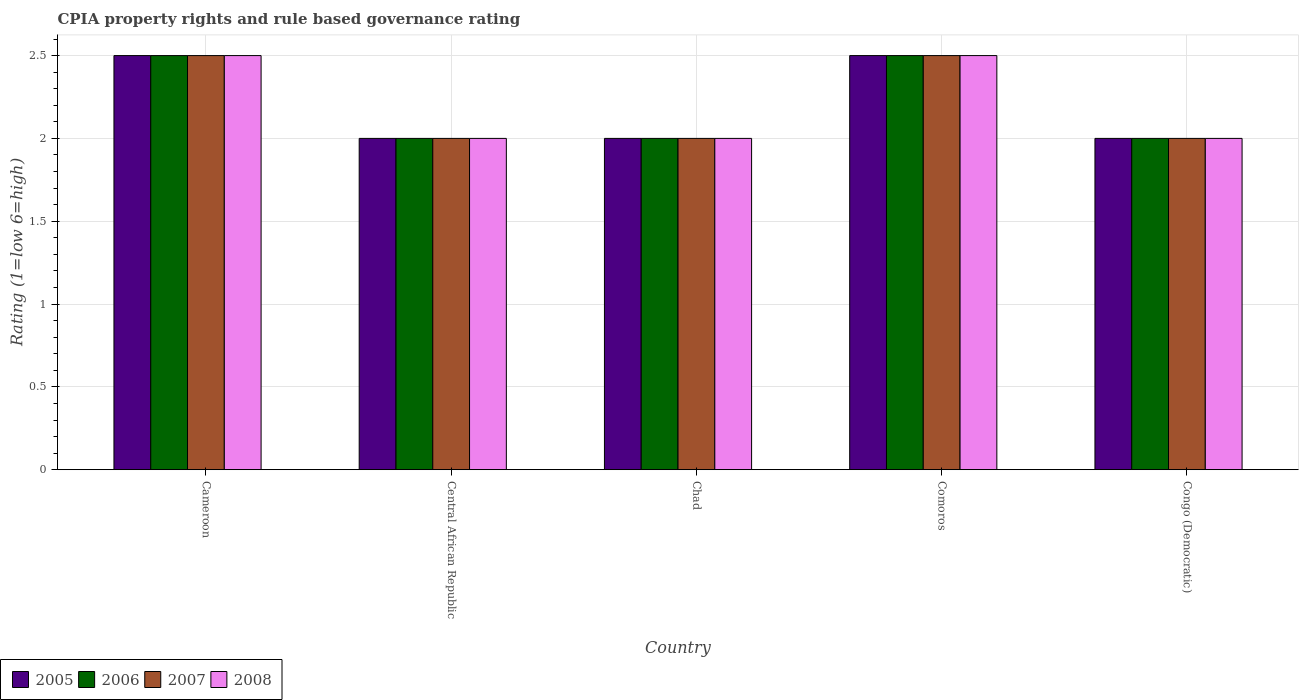How many different coloured bars are there?
Your response must be concise. 4. Are the number of bars on each tick of the X-axis equal?
Give a very brief answer. Yes. How many bars are there on the 4th tick from the right?
Your answer should be compact. 4. What is the label of the 5th group of bars from the left?
Offer a terse response. Congo (Democratic). In how many cases, is the number of bars for a given country not equal to the number of legend labels?
Provide a short and direct response. 0. Across all countries, what is the maximum CPIA rating in 2005?
Provide a succinct answer. 2.5. Across all countries, what is the minimum CPIA rating in 2008?
Offer a terse response. 2. In which country was the CPIA rating in 2008 maximum?
Provide a succinct answer. Cameroon. In which country was the CPIA rating in 2007 minimum?
Provide a short and direct response. Central African Republic. What is the total CPIA rating in 2006 in the graph?
Keep it short and to the point. 11. What is the average CPIA rating in 2005 per country?
Your response must be concise. 2.2. Is the CPIA rating in 2008 in Cameroon less than that in Chad?
Offer a terse response. No. Is the sum of the CPIA rating in 2008 in Cameroon and Comoros greater than the maximum CPIA rating in 2006 across all countries?
Your answer should be compact. Yes. What does the 3rd bar from the left in Comoros represents?
Provide a succinct answer. 2007. How many bars are there?
Offer a terse response. 20. Are all the bars in the graph horizontal?
Provide a short and direct response. No. What is the difference between two consecutive major ticks on the Y-axis?
Make the answer very short. 0.5. Does the graph contain any zero values?
Offer a terse response. No. Where does the legend appear in the graph?
Offer a very short reply. Bottom left. What is the title of the graph?
Offer a very short reply. CPIA property rights and rule based governance rating. What is the label or title of the Y-axis?
Make the answer very short. Rating (1=low 6=high). What is the Rating (1=low 6=high) in 2005 in Cameroon?
Provide a short and direct response. 2.5. What is the Rating (1=low 6=high) in 2007 in Cameroon?
Your answer should be compact. 2.5. What is the Rating (1=low 6=high) of 2008 in Cameroon?
Keep it short and to the point. 2.5. What is the Rating (1=low 6=high) in 2006 in Central African Republic?
Offer a very short reply. 2. What is the Rating (1=low 6=high) in 2005 in Chad?
Your response must be concise. 2. What is the Rating (1=low 6=high) of 2006 in Chad?
Offer a terse response. 2. What is the Rating (1=low 6=high) of 2008 in Chad?
Your answer should be compact. 2. What is the Rating (1=low 6=high) in 2005 in Comoros?
Your answer should be very brief. 2.5. What is the Rating (1=low 6=high) of 2006 in Comoros?
Make the answer very short. 2.5. What is the Rating (1=low 6=high) of 2007 in Comoros?
Offer a very short reply. 2.5. What is the Rating (1=low 6=high) of 2008 in Comoros?
Ensure brevity in your answer.  2.5. What is the Rating (1=low 6=high) of 2008 in Congo (Democratic)?
Give a very brief answer. 2. Across all countries, what is the maximum Rating (1=low 6=high) of 2005?
Your answer should be compact. 2.5. Across all countries, what is the maximum Rating (1=low 6=high) of 2007?
Your answer should be compact. 2.5. Across all countries, what is the minimum Rating (1=low 6=high) of 2005?
Ensure brevity in your answer.  2. Across all countries, what is the minimum Rating (1=low 6=high) of 2006?
Make the answer very short. 2. Across all countries, what is the minimum Rating (1=low 6=high) of 2007?
Give a very brief answer. 2. What is the total Rating (1=low 6=high) of 2005 in the graph?
Your answer should be compact. 11. What is the total Rating (1=low 6=high) of 2008 in the graph?
Make the answer very short. 11. What is the difference between the Rating (1=low 6=high) of 2005 in Cameroon and that in Central African Republic?
Provide a short and direct response. 0.5. What is the difference between the Rating (1=low 6=high) of 2006 in Cameroon and that in Central African Republic?
Your answer should be very brief. 0.5. What is the difference between the Rating (1=low 6=high) of 2008 in Cameroon and that in Central African Republic?
Your response must be concise. 0.5. What is the difference between the Rating (1=low 6=high) of 2005 in Cameroon and that in Comoros?
Ensure brevity in your answer.  0. What is the difference between the Rating (1=low 6=high) of 2008 in Cameroon and that in Comoros?
Provide a succinct answer. 0. What is the difference between the Rating (1=low 6=high) in 2007 in Cameroon and that in Congo (Democratic)?
Your answer should be compact. 0.5. What is the difference between the Rating (1=low 6=high) of 2006 in Central African Republic and that in Chad?
Provide a succinct answer. 0. What is the difference between the Rating (1=low 6=high) of 2005 in Central African Republic and that in Comoros?
Ensure brevity in your answer.  -0.5. What is the difference between the Rating (1=low 6=high) in 2007 in Central African Republic and that in Comoros?
Keep it short and to the point. -0.5. What is the difference between the Rating (1=low 6=high) of 2008 in Central African Republic and that in Comoros?
Your response must be concise. -0.5. What is the difference between the Rating (1=low 6=high) of 2006 in Central African Republic and that in Congo (Democratic)?
Offer a terse response. 0. What is the difference between the Rating (1=low 6=high) in 2007 in Central African Republic and that in Congo (Democratic)?
Ensure brevity in your answer.  0. What is the difference between the Rating (1=low 6=high) of 2008 in Central African Republic and that in Congo (Democratic)?
Give a very brief answer. 0. What is the difference between the Rating (1=low 6=high) in 2008 in Chad and that in Comoros?
Your answer should be very brief. -0.5. What is the difference between the Rating (1=low 6=high) of 2005 in Chad and that in Congo (Democratic)?
Keep it short and to the point. 0. What is the difference between the Rating (1=low 6=high) in 2006 in Chad and that in Congo (Democratic)?
Offer a very short reply. 0. What is the difference between the Rating (1=low 6=high) in 2007 in Chad and that in Congo (Democratic)?
Make the answer very short. 0. What is the difference between the Rating (1=low 6=high) in 2005 in Comoros and that in Congo (Democratic)?
Ensure brevity in your answer.  0.5. What is the difference between the Rating (1=low 6=high) of 2006 in Comoros and that in Congo (Democratic)?
Give a very brief answer. 0.5. What is the difference between the Rating (1=low 6=high) of 2007 in Comoros and that in Congo (Democratic)?
Provide a short and direct response. 0.5. What is the difference between the Rating (1=low 6=high) in 2005 in Cameroon and the Rating (1=low 6=high) in 2006 in Central African Republic?
Your response must be concise. 0.5. What is the difference between the Rating (1=low 6=high) of 2005 in Cameroon and the Rating (1=low 6=high) of 2008 in Central African Republic?
Offer a terse response. 0.5. What is the difference between the Rating (1=low 6=high) of 2005 in Cameroon and the Rating (1=low 6=high) of 2008 in Chad?
Your response must be concise. 0.5. What is the difference between the Rating (1=low 6=high) in 2006 in Cameroon and the Rating (1=low 6=high) in 2007 in Chad?
Offer a very short reply. 0.5. What is the difference between the Rating (1=low 6=high) of 2006 in Cameroon and the Rating (1=low 6=high) of 2008 in Chad?
Your response must be concise. 0.5. What is the difference between the Rating (1=low 6=high) in 2007 in Cameroon and the Rating (1=low 6=high) in 2008 in Chad?
Offer a terse response. 0.5. What is the difference between the Rating (1=low 6=high) in 2005 in Cameroon and the Rating (1=low 6=high) in 2007 in Comoros?
Your answer should be compact. 0. What is the difference between the Rating (1=low 6=high) in 2005 in Cameroon and the Rating (1=low 6=high) in 2008 in Comoros?
Your answer should be very brief. 0. What is the difference between the Rating (1=low 6=high) in 2006 in Cameroon and the Rating (1=low 6=high) in 2007 in Comoros?
Offer a very short reply. 0. What is the difference between the Rating (1=low 6=high) of 2005 in Cameroon and the Rating (1=low 6=high) of 2006 in Congo (Democratic)?
Offer a very short reply. 0.5. What is the difference between the Rating (1=low 6=high) in 2005 in Cameroon and the Rating (1=low 6=high) in 2007 in Congo (Democratic)?
Ensure brevity in your answer.  0.5. What is the difference between the Rating (1=low 6=high) of 2006 in Cameroon and the Rating (1=low 6=high) of 2008 in Congo (Democratic)?
Give a very brief answer. 0.5. What is the difference between the Rating (1=low 6=high) in 2007 in Cameroon and the Rating (1=low 6=high) in 2008 in Congo (Democratic)?
Your answer should be very brief. 0.5. What is the difference between the Rating (1=low 6=high) of 2005 in Central African Republic and the Rating (1=low 6=high) of 2007 in Chad?
Ensure brevity in your answer.  0. What is the difference between the Rating (1=low 6=high) of 2005 in Central African Republic and the Rating (1=low 6=high) of 2008 in Comoros?
Your answer should be very brief. -0.5. What is the difference between the Rating (1=low 6=high) in 2006 in Central African Republic and the Rating (1=low 6=high) in 2008 in Comoros?
Offer a very short reply. -0.5. What is the difference between the Rating (1=low 6=high) in 2007 in Central African Republic and the Rating (1=low 6=high) in 2008 in Comoros?
Ensure brevity in your answer.  -0.5. What is the difference between the Rating (1=low 6=high) of 2005 in Central African Republic and the Rating (1=low 6=high) of 2006 in Congo (Democratic)?
Your answer should be very brief. 0. What is the difference between the Rating (1=low 6=high) in 2007 in Central African Republic and the Rating (1=low 6=high) in 2008 in Congo (Democratic)?
Your response must be concise. 0. What is the difference between the Rating (1=low 6=high) in 2005 in Chad and the Rating (1=low 6=high) in 2006 in Comoros?
Offer a very short reply. -0.5. What is the difference between the Rating (1=low 6=high) of 2005 in Chad and the Rating (1=low 6=high) of 2007 in Comoros?
Your response must be concise. -0.5. What is the difference between the Rating (1=low 6=high) in 2005 in Chad and the Rating (1=low 6=high) in 2008 in Comoros?
Give a very brief answer. -0.5. What is the difference between the Rating (1=low 6=high) in 2006 in Chad and the Rating (1=low 6=high) in 2007 in Comoros?
Your answer should be compact. -0.5. What is the difference between the Rating (1=low 6=high) in 2006 in Chad and the Rating (1=low 6=high) in 2008 in Comoros?
Make the answer very short. -0.5. What is the difference between the Rating (1=low 6=high) of 2007 in Chad and the Rating (1=low 6=high) of 2008 in Comoros?
Your answer should be very brief. -0.5. What is the difference between the Rating (1=low 6=high) in 2005 in Chad and the Rating (1=low 6=high) in 2007 in Congo (Democratic)?
Provide a succinct answer. 0. What is the difference between the Rating (1=low 6=high) in 2006 in Chad and the Rating (1=low 6=high) in 2007 in Congo (Democratic)?
Provide a short and direct response. 0. What is the difference between the Rating (1=low 6=high) in 2007 in Chad and the Rating (1=low 6=high) in 2008 in Congo (Democratic)?
Ensure brevity in your answer.  0. What is the difference between the Rating (1=low 6=high) of 2006 in Comoros and the Rating (1=low 6=high) of 2007 in Congo (Democratic)?
Ensure brevity in your answer.  0.5. What is the average Rating (1=low 6=high) in 2005 per country?
Your answer should be compact. 2.2. What is the average Rating (1=low 6=high) in 2008 per country?
Make the answer very short. 2.2. What is the difference between the Rating (1=low 6=high) of 2005 and Rating (1=low 6=high) of 2006 in Cameroon?
Provide a short and direct response. 0. What is the difference between the Rating (1=low 6=high) of 2005 and Rating (1=low 6=high) of 2007 in Cameroon?
Offer a very short reply. 0. What is the difference between the Rating (1=low 6=high) in 2006 and Rating (1=low 6=high) in 2008 in Cameroon?
Provide a short and direct response. 0. What is the difference between the Rating (1=low 6=high) in 2007 and Rating (1=low 6=high) in 2008 in Cameroon?
Provide a short and direct response. 0. What is the difference between the Rating (1=low 6=high) in 2005 and Rating (1=low 6=high) in 2006 in Central African Republic?
Your answer should be very brief. 0. What is the difference between the Rating (1=low 6=high) in 2005 and Rating (1=low 6=high) in 2007 in Central African Republic?
Offer a terse response. 0. What is the difference between the Rating (1=low 6=high) of 2006 and Rating (1=low 6=high) of 2008 in Central African Republic?
Provide a short and direct response. 0. What is the difference between the Rating (1=low 6=high) of 2005 and Rating (1=low 6=high) of 2006 in Chad?
Offer a very short reply. 0. What is the difference between the Rating (1=low 6=high) in 2005 and Rating (1=low 6=high) in 2007 in Chad?
Your answer should be very brief. 0. What is the difference between the Rating (1=low 6=high) of 2005 and Rating (1=low 6=high) of 2008 in Chad?
Keep it short and to the point. 0. What is the difference between the Rating (1=low 6=high) in 2007 and Rating (1=low 6=high) in 2008 in Chad?
Provide a short and direct response. 0. What is the difference between the Rating (1=low 6=high) in 2005 and Rating (1=low 6=high) in 2006 in Comoros?
Provide a succinct answer. 0. What is the difference between the Rating (1=low 6=high) of 2005 and Rating (1=low 6=high) of 2007 in Congo (Democratic)?
Keep it short and to the point. 0. What is the difference between the Rating (1=low 6=high) of 2006 and Rating (1=low 6=high) of 2007 in Congo (Democratic)?
Your answer should be very brief. 0. What is the difference between the Rating (1=low 6=high) in 2007 and Rating (1=low 6=high) in 2008 in Congo (Democratic)?
Your answer should be compact. 0. What is the ratio of the Rating (1=low 6=high) of 2005 in Cameroon to that in Central African Republic?
Provide a succinct answer. 1.25. What is the ratio of the Rating (1=low 6=high) of 2007 in Cameroon to that in Central African Republic?
Offer a very short reply. 1.25. What is the ratio of the Rating (1=low 6=high) in 2005 in Cameroon to that in Comoros?
Offer a terse response. 1. What is the ratio of the Rating (1=low 6=high) of 2007 in Cameroon to that in Comoros?
Offer a terse response. 1. What is the ratio of the Rating (1=low 6=high) of 2005 in Central African Republic to that in Chad?
Offer a terse response. 1. What is the ratio of the Rating (1=low 6=high) in 2007 in Central African Republic to that in Chad?
Give a very brief answer. 1. What is the ratio of the Rating (1=low 6=high) of 2008 in Central African Republic to that in Chad?
Keep it short and to the point. 1. What is the ratio of the Rating (1=low 6=high) of 2006 in Central African Republic to that in Comoros?
Your answer should be very brief. 0.8. What is the ratio of the Rating (1=low 6=high) in 2007 in Central African Republic to that in Comoros?
Your answer should be compact. 0.8. What is the ratio of the Rating (1=low 6=high) in 2005 in Central African Republic to that in Congo (Democratic)?
Ensure brevity in your answer.  1. What is the ratio of the Rating (1=low 6=high) in 2006 in Central African Republic to that in Congo (Democratic)?
Make the answer very short. 1. What is the ratio of the Rating (1=low 6=high) in 2008 in Central African Republic to that in Congo (Democratic)?
Offer a very short reply. 1. What is the ratio of the Rating (1=low 6=high) in 2005 in Chad to that in Comoros?
Give a very brief answer. 0.8. What is the ratio of the Rating (1=low 6=high) of 2006 in Chad to that in Comoros?
Offer a terse response. 0.8. What is the ratio of the Rating (1=low 6=high) in 2006 in Chad to that in Congo (Democratic)?
Your answer should be very brief. 1. What is the ratio of the Rating (1=low 6=high) of 2006 in Comoros to that in Congo (Democratic)?
Your answer should be very brief. 1.25. What is the ratio of the Rating (1=low 6=high) in 2007 in Comoros to that in Congo (Democratic)?
Keep it short and to the point. 1.25. What is the difference between the highest and the second highest Rating (1=low 6=high) of 2006?
Make the answer very short. 0. What is the difference between the highest and the second highest Rating (1=low 6=high) in 2007?
Your response must be concise. 0. What is the difference between the highest and the lowest Rating (1=low 6=high) in 2005?
Your answer should be compact. 0.5. What is the difference between the highest and the lowest Rating (1=low 6=high) in 2008?
Offer a very short reply. 0.5. 